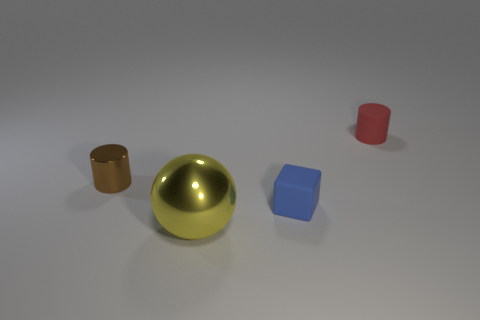What material is the brown cylinder that is the same size as the red cylinder?
Your response must be concise. Metal. There is a tiny cylinder that is to the left of the large yellow shiny object; are there any tiny brown cylinders that are on the right side of it?
Provide a succinct answer. No. How many other objects are there of the same color as the rubber cylinder?
Your answer should be very brief. 0. The yellow ball is what size?
Provide a short and direct response. Large. Are any blue matte things visible?
Give a very brief answer. Yes. Are there more rubber cylinders that are on the right side of the red matte object than big shiny objects left of the small brown thing?
Keep it short and to the point. No. What is the material of the tiny object that is both in front of the small red object and on the right side of the shiny ball?
Make the answer very short. Rubber. Does the brown metallic thing have the same shape as the small red rubber object?
Your answer should be compact. Yes. Is there any other thing that is the same size as the yellow thing?
Offer a terse response. No. What number of small red matte cylinders are right of the small brown thing?
Offer a very short reply. 1. 